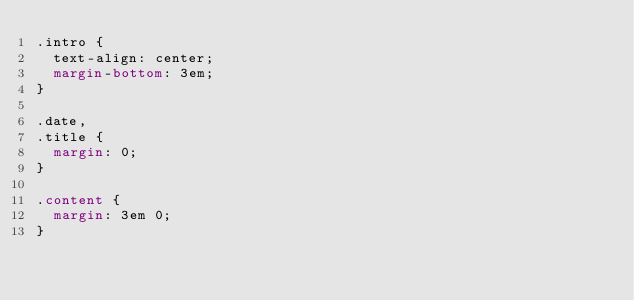Convert code to text. <code><loc_0><loc_0><loc_500><loc_500><_CSS_>.intro {
  text-align: center;
  margin-bottom: 3em;
}

.date,
.title {
  margin: 0;
}

.content {
  margin: 3em 0;
}
</code> 